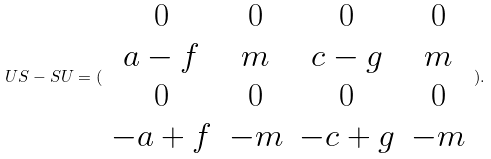<formula> <loc_0><loc_0><loc_500><loc_500>U S - S U = ( \begin{array} { c c c c } 0 & 0 & 0 & 0 \\ a - f & m & c - g & m \\ 0 & 0 & 0 & 0 \\ - a + f & - m & - c + g & - m \end{array} ) .</formula> 